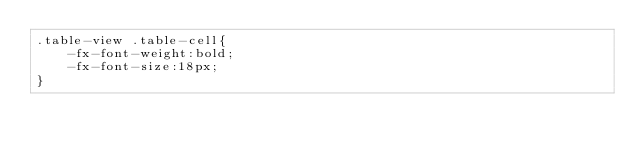Convert code to text. <code><loc_0><loc_0><loc_500><loc_500><_CSS_>.table-view .table-cell{
    -fx-font-weight:bold;
    -fx-font-size:18px;
}</code> 